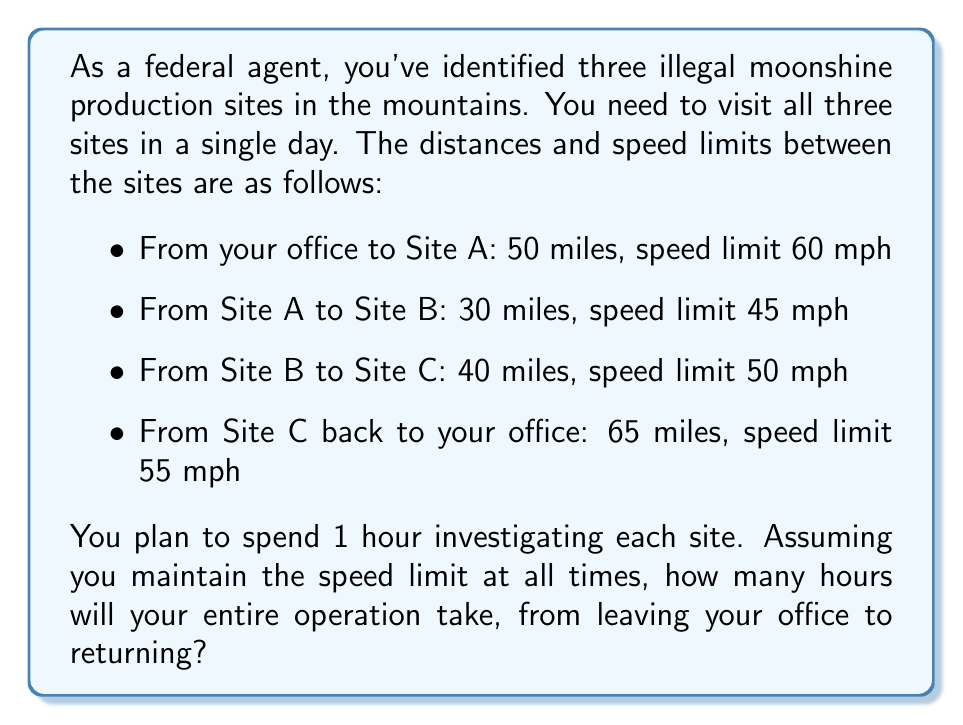Help me with this question. To solve this problem, we need to calculate the travel time for each leg of the journey and add the investigation time at each site. Let's break it down step by step:

1. Calculate travel time for each leg:
   
   Time = Distance / Speed

   a) Office to Site A: 
      $t_1 = \frac{50 \text{ miles}}{60 \text{ mph}} = \frac{5}{6} \text{ hours}$

   b) Site A to Site B:
      $t_2 = \frac{30 \text{ miles}}{45 \text{ mph}} = \frac{2}{3} \text{ hours}$

   c) Site B to Site C:
      $t_3 = \frac{40 \text{ miles}}{50 \text{ mph}} = \frac{4}{5} \text{ hours}$

   d) Site C to Office:
      $t_4 = \frac{65 \text{ miles}}{55 \text{ mph}} = \frac{13}{11} \text{ hours}$

2. Sum up all travel times:
   $T_{travel} = t_1 + t_2 + t_3 + t_4 = \frac{5}{6} + \frac{2}{3} + \frac{4}{5} + \frac{13}{11}$

3. Convert to a common denominator:
   $T_{travel} = \frac{55}{66} + \frac{44}{66} + \frac{53}{66} + \frac{78}{66} = \frac{230}{66} \text{ hours}$

4. Add investigation time:
   $T_{investigation} = 3 \text{ hours}$ (1 hour per site)

5. Calculate total time:
   $T_{total} = T_{travel} + T_{investigation} = \frac{230}{66} + 3 = \frac{230}{66} + \frac{198}{66} = \frac{428}{66}$

6. Simplify the fraction:
   $\frac{428}{66} = 6\frac{32}{66} = 6\frac{16}{33} \text{ hours}$
Answer: The entire operation will take $6\frac{16}{33}$ hours, or approximately 6 hours and 29 minutes. 